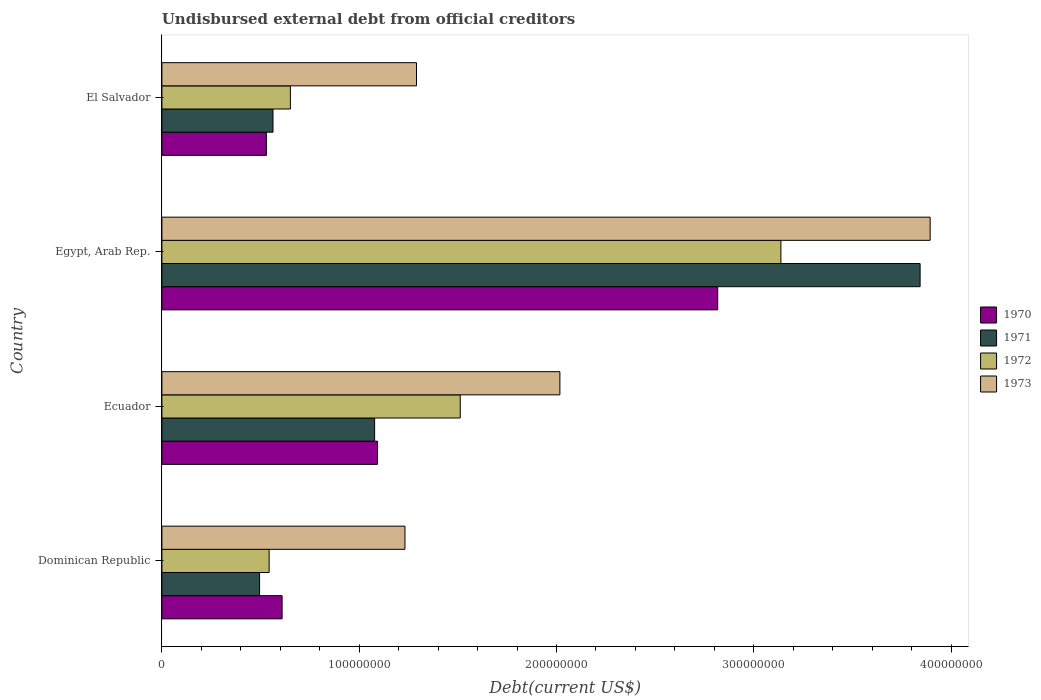How many different coloured bars are there?
Provide a succinct answer. 4. Are the number of bars on each tick of the Y-axis equal?
Make the answer very short. Yes. How many bars are there on the 4th tick from the top?
Make the answer very short. 4. How many bars are there on the 4th tick from the bottom?
Offer a very short reply. 4. What is the label of the 4th group of bars from the top?
Keep it short and to the point. Dominican Republic. What is the total debt in 1970 in Ecuador?
Offer a very short reply. 1.09e+08. Across all countries, what is the maximum total debt in 1972?
Your response must be concise. 3.14e+08. Across all countries, what is the minimum total debt in 1973?
Ensure brevity in your answer.  1.23e+08. In which country was the total debt in 1971 maximum?
Your answer should be very brief. Egypt, Arab Rep. In which country was the total debt in 1971 minimum?
Give a very brief answer. Dominican Republic. What is the total total debt in 1970 in the graph?
Your response must be concise. 5.05e+08. What is the difference between the total debt in 1970 in Dominican Republic and that in Egypt, Arab Rep.?
Offer a very short reply. -2.21e+08. What is the difference between the total debt in 1972 in Dominican Republic and the total debt in 1971 in El Salvador?
Give a very brief answer. -1.96e+06. What is the average total debt in 1971 per country?
Ensure brevity in your answer.  1.49e+08. What is the difference between the total debt in 1971 and total debt in 1972 in Dominican Republic?
Make the answer very short. -4.85e+06. In how many countries, is the total debt in 1972 greater than 100000000 US$?
Provide a succinct answer. 2. What is the ratio of the total debt in 1972 in Dominican Republic to that in Egypt, Arab Rep.?
Give a very brief answer. 0.17. Is the total debt in 1970 in Ecuador less than that in Egypt, Arab Rep.?
Provide a short and direct response. Yes. What is the difference between the highest and the second highest total debt in 1970?
Offer a terse response. 1.72e+08. What is the difference between the highest and the lowest total debt in 1971?
Your answer should be very brief. 3.35e+08. In how many countries, is the total debt in 1972 greater than the average total debt in 1972 taken over all countries?
Keep it short and to the point. 2. Is it the case that in every country, the sum of the total debt in 1973 and total debt in 1970 is greater than the sum of total debt in 1971 and total debt in 1972?
Your answer should be very brief. No. Is it the case that in every country, the sum of the total debt in 1970 and total debt in 1973 is greater than the total debt in 1972?
Provide a succinct answer. Yes. Are all the bars in the graph horizontal?
Ensure brevity in your answer.  Yes. Are the values on the major ticks of X-axis written in scientific E-notation?
Keep it short and to the point. No. Does the graph contain any zero values?
Ensure brevity in your answer.  No. Where does the legend appear in the graph?
Provide a succinct answer. Center right. What is the title of the graph?
Your response must be concise. Undisbursed external debt from official creditors. Does "1981" appear as one of the legend labels in the graph?
Keep it short and to the point. No. What is the label or title of the X-axis?
Offer a terse response. Debt(current US$). What is the Debt(current US$) in 1970 in Dominican Republic?
Your response must be concise. 6.09e+07. What is the Debt(current US$) in 1971 in Dominican Republic?
Give a very brief answer. 4.95e+07. What is the Debt(current US$) in 1972 in Dominican Republic?
Your response must be concise. 5.44e+07. What is the Debt(current US$) of 1973 in Dominican Republic?
Provide a succinct answer. 1.23e+08. What is the Debt(current US$) in 1970 in Ecuador?
Keep it short and to the point. 1.09e+08. What is the Debt(current US$) of 1971 in Ecuador?
Your answer should be very brief. 1.08e+08. What is the Debt(current US$) in 1972 in Ecuador?
Give a very brief answer. 1.51e+08. What is the Debt(current US$) in 1973 in Ecuador?
Give a very brief answer. 2.02e+08. What is the Debt(current US$) in 1970 in Egypt, Arab Rep.?
Offer a terse response. 2.82e+08. What is the Debt(current US$) of 1971 in Egypt, Arab Rep.?
Provide a short and direct response. 3.84e+08. What is the Debt(current US$) of 1972 in Egypt, Arab Rep.?
Keep it short and to the point. 3.14e+08. What is the Debt(current US$) of 1973 in Egypt, Arab Rep.?
Your answer should be very brief. 3.89e+08. What is the Debt(current US$) in 1970 in El Salvador?
Your response must be concise. 5.30e+07. What is the Debt(current US$) in 1971 in El Salvador?
Ensure brevity in your answer.  5.63e+07. What is the Debt(current US$) in 1972 in El Salvador?
Offer a very short reply. 6.51e+07. What is the Debt(current US$) in 1973 in El Salvador?
Your answer should be very brief. 1.29e+08. Across all countries, what is the maximum Debt(current US$) in 1970?
Make the answer very short. 2.82e+08. Across all countries, what is the maximum Debt(current US$) of 1971?
Provide a short and direct response. 3.84e+08. Across all countries, what is the maximum Debt(current US$) of 1972?
Provide a succinct answer. 3.14e+08. Across all countries, what is the maximum Debt(current US$) of 1973?
Give a very brief answer. 3.89e+08. Across all countries, what is the minimum Debt(current US$) of 1970?
Your answer should be compact. 5.30e+07. Across all countries, what is the minimum Debt(current US$) in 1971?
Provide a succinct answer. 4.95e+07. Across all countries, what is the minimum Debt(current US$) in 1972?
Provide a succinct answer. 5.44e+07. Across all countries, what is the minimum Debt(current US$) in 1973?
Ensure brevity in your answer.  1.23e+08. What is the total Debt(current US$) in 1970 in the graph?
Offer a very short reply. 5.05e+08. What is the total Debt(current US$) of 1971 in the graph?
Offer a very short reply. 5.98e+08. What is the total Debt(current US$) of 1972 in the graph?
Make the answer very short. 5.84e+08. What is the total Debt(current US$) of 1973 in the graph?
Your response must be concise. 8.43e+08. What is the difference between the Debt(current US$) of 1970 in Dominican Republic and that in Ecuador?
Provide a short and direct response. -4.84e+07. What is the difference between the Debt(current US$) in 1971 in Dominican Republic and that in Ecuador?
Provide a short and direct response. -5.83e+07. What is the difference between the Debt(current US$) of 1972 in Dominican Republic and that in Ecuador?
Your answer should be compact. -9.69e+07. What is the difference between the Debt(current US$) in 1973 in Dominican Republic and that in Ecuador?
Offer a very short reply. -7.85e+07. What is the difference between the Debt(current US$) of 1970 in Dominican Republic and that in Egypt, Arab Rep.?
Provide a short and direct response. -2.21e+08. What is the difference between the Debt(current US$) of 1971 in Dominican Republic and that in Egypt, Arab Rep.?
Provide a short and direct response. -3.35e+08. What is the difference between the Debt(current US$) of 1972 in Dominican Republic and that in Egypt, Arab Rep.?
Keep it short and to the point. -2.59e+08. What is the difference between the Debt(current US$) of 1973 in Dominican Republic and that in Egypt, Arab Rep.?
Keep it short and to the point. -2.66e+08. What is the difference between the Debt(current US$) of 1970 in Dominican Republic and that in El Salvador?
Provide a short and direct response. 7.96e+06. What is the difference between the Debt(current US$) in 1971 in Dominican Republic and that in El Salvador?
Make the answer very short. -6.81e+06. What is the difference between the Debt(current US$) in 1972 in Dominican Republic and that in El Salvador?
Your answer should be very brief. -1.08e+07. What is the difference between the Debt(current US$) in 1973 in Dominican Republic and that in El Salvador?
Your answer should be compact. -5.85e+06. What is the difference between the Debt(current US$) in 1970 in Ecuador and that in Egypt, Arab Rep.?
Your answer should be very brief. -1.72e+08. What is the difference between the Debt(current US$) of 1971 in Ecuador and that in Egypt, Arab Rep.?
Your answer should be compact. -2.76e+08. What is the difference between the Debt(current US$) of 1972 in Ecuador and that in Egypt, Arab Rep.?
Make the answer very short. -1.63e+08. What is the difference between the Debt(current US$) of 1973 in Ecuador and that in Egypt, Arab Rep.?
Make the answer very short. -1.88e+08. What is the difference between the Debt(current US$) of 1970 in Ecuador and that in El Salvador?
Your response must be concise. 5.63e+07. What is the difference between the Debt(current US$) in 1971 in Ecuador and that in El Salvador?
Your answer should be compact. 5.15e+07. What is the difference between the Debt(current US$) in 1972 in Ecuador and that in El Salvador?
Your response must be concise. 8.61e+07. What is the difference between the Debt(current US$) of 1973 in Ecuador and that in El Salvador?
Your answer should be very brief. 7.27e+07. What is the difference between the Debt(current US$) of 1970 in Egypt, Arab Rep. and that in El Salvador?
Offer a very short reply. 2.29e+08. What is the difference between the Debt(current US$) of 1971 in Egypt, Arab Rep. and that in El Salvador?
Make the answer very short. 3.28e+08. What is the difference between the Debt(current US$) of 1972 in Egypt, Arab Rep. and that in El Salvador?
Provide a succinct answer. 2.49e+08. What is the difference between the Debt(current US$) in 1973 in Egypt, Arab Rep. and that in El Salvador?
Offer a terse response. 2.60e+08. What is the difference between the Debt(current US$) of 1970 in Dominican Republic and the Debt(current US$) of 1971 in Ecuador?
Provide a short and direct response. -4.69e+07. What is the difference between the Debt(current US$) in 1970 in Dominican Republic and the Debt(current US$) in 1972 in Ecuador?
Offer a terse response. -9.03e+07. What is the difference between the Debt(current US$) of 1970 in Dominican Republic and the Debt(current US$) of 1973 in Ecuador?
Give a very brief answer. -1.41e+08. What is the difference between the Debt(current US$) in 1971 in Dominican Republic and the Debt(current US$) in 1972 in Ecuador?
Make the answer very short. -1.02e+08. What is the difference between the Debt(current US$) in 1971 in Dominican Republic and the Debt(current US$) in 1973 in Ecuador?
Give a very brief answer. -1.52e+08. What is the difference between the Debt(current US$) in 1972 in Dominican Republic and the Debt(current US$) in 1973 in Ecuador?
Keep it short and to the point. -1.47e+08. What is the difference between the Debt(current US$) in 1970 in Dominican Republic and the Debt(current US$) in 1971 in Egypt, Arab Rep.?
Your answer should be very brief. -3.23e+08. What is the difference between the Debt(current US$) in 1970 in Dominican Republic and the Debt(current US$) in 1972 in Egypt, Arab Rep.?
Your answer should be compact. -2.53e+08. What is the difference between the Debt(current US$) in 1970 in Dominican Republic and the Debt(current US$) in 1973 in Egypt, Arab Rep.?
Your response must be concise. -3.28e+08. What is the difference between the Debt(current US$) of 1971 in Dominican Republic and the Debt(current US$) of 1972 in Egypt, Arab Rep.?
Your answer should be compact. -2.64e+08. What is the difference between the Debt(current US$) of 1971 in Dominican Republic and the Debt(current US$) of 1973 in Egypt, Arab Rep.?
Your response must be concise. -3.40e+08. What is the difference between the Debt(current US$) of 1972 in Dominican Republic and the Debt(current US$) of 1973 in Egypt, Arab Rep.?
Ensure brevity in your answer.  -3.35e+08. What is the difference between the Debt(current US$) in 1970 in Dominican Republic and the Debt(current US$) in 1971 in El Salvador?
Your answer should be very brief. 4.62e+06. What is the difference between the Debt(current US$) in 1970 in Dominican Republic and the Debt(current US$) in 1972 in El Salvador?
Give a very brief answer. -4.20e+06. What is the difference between the Debt(current US$) in 1970 in Dominican Republic and the Debt(current US$) in 1973 in El Salvador?
Your answer should be very brief. -6.81e+07. What is the difference between the Debt(current US$) of 1971 in Dominican Republic and the Debt(current US$) of 1972 in El Salvador?
Your answer should be compact. -1.56e+07. What is the difference between the Debt(current US$) of 1971 in Dominican Republic and the Debt(current US$) of 1973 in El Salvador?
Provide a succinct answer. -7.95e+07. What is the difference between the Debt(current US$) of 1972 in Dominican Republic and the Debt(current US$) of 1973 in El Salvador?
Offer a very short reply. -7.47e+07. What is the difference between the Debt(current US$) in 1970 in Ecuador and the Debt(current US$) in 1971 in Egypt, Arab Rep.?
Provide a succinct answer. -2.75e+08. What is the difference between the Debt(current US$) in 1970 in Ecuador and the Debt(current US$) in 1972 in Egypt, Arab Rep.?
Your answer should be very brief. -2.04e+08. What is the difference between the Debt(current US$) in 1970 in Ecuador and the Debt(current US$) in 1973 in Egypt, Arab Rep.?
Your answer should be compact. -2.80e+08. What is the difference between the Debt(current US$) in 1971 in Ecuador and the Debt(current US$) in 1972 in Egypt, Arab Rep.?
Your answer should be compact. -2.06e+08. What is the difference between the Debt(current US$) of 1971 in Ecuador and the Debt(current US$) of 1973 in Egypt, Arab Rep.?
Give a very brief answer. -2.82e+08. What is the difference between the Debt(current US$) of 1972 in Ecuador and the Debt(current US$) of 1973 in Egypt, Arab Rep.?
Give a very brief answer. -2.38e+08. What is the difference between the Debt(current US$) of 1970 in Ecuador and the Debt(current US$) of 1971 in El Salvador?
Your answer should be compact. 5.30e+07. What is the difference between the Debt(current US$) of 1970 in Ecuador and the Debt(current US$) of 1972 in El Salvador?
Ensure brevity in your answer.  4.42e+07. What is the difference between the Debt(current US$) in 1970 in Ecuador and the Debt(current US$) in 1973 in El Salvador?
Your answer should be very brief. -1.98e+07. What is the difference between the Debt(current US$) of 1971 in Ecuador and the Debt(current US$) of 1972 in El Salvador?
Your answer should be very brief. 4.27e+07. What is the difference between the Debt(current US$) of 1971 in Ecuador and the Debt(current US$) of 1973 in El Salvador?
Your answer should be compact. -2.12e+07. What is the difference between the Debt(current US$) in 1972 in Ecuador and the Debt(current US$) in 1973 in El Salvador?
Keep it short and to the point. 2.22e+07. What is the difference between the Debt(current US$) in 1970 in Egypt, Arab Rep. and the Debt(current US$) in 1971 in El Salvador?
Your answer should be compact. 2.25e+08. What is the difference between the Debt(current US$) in 1970 in Egypt, Arab Rep. and the Debt(current US$) in 1972 in El Salvador?
Ensure brevity in your answer.  2.17e+08. What is the difference between the Debt(current US$) in 1970 in Egypt, Arab Rep. and the Debt(current US$) in 1973 in El Salvador?
Your answer should be very brief. 1.53e+08. What is the difference between the Debt(current US$) in 1971 in Egypt, Arab Rep. and the Debt(current US$) in 1972 in El Salvador?
Offer a very short reply. 3.19e+08. What is the difference between the Debt(current US$) of 1971 in Egypt, Arab Rep. and the Debt(current US$) of 1973 in El Salvador?
Your response must be concise. 2.55e+08. What is the difference between the Debt(current US$) in 1972 in Egypt, Arab Rep. and the Debt(current US$) in 1973 in El Salvador?
Keep it short and to the point. 1.85e+08. What is the average Debt(current US$) in 1970 per country?
Ensure brevity in your answer.  1.26e+08. What is the average Debt(current US$) of 1971 per country?
Make the answer very short. 1.49e+08. What is the average Debt(current US$) of 1972 per country?
Your answer should be very brief. 1.46e+08. What is the average Debt(current US$) of 1973 per country?
Offer a very short reply. 2.11e+08. What is the difference between the Debt(current US$) of 1970 and Debt(current US$) of 1971 in Dominican Republic?
Offer a very short reply. 1.14e+07. What is the difference between the Debt(current US$) of 1970 and Debt(current US$) of 1972 in Dominican Republic?
Keep it short and to the point. 6.57e+06. What is the difference between the Debt(current US$) of 1970 and Debt(current US$) of 1973 in Dominican Republic?
Your answer should be compact. -6.23e+07. What is the difference between the Debt(current US$) of 1971 and Debt(current US$) of 1972 in Dominican Republic?
Make the answer very short. -4.85e+06. What is the difference between the Debt(current US$) of 1971 and Debt(current US$) of 1973 in Dominican Republic?
Your answer should be very brief. -7.37e+07. What is the difference between the Debt(current US$) of 1972 and Debt(current US$) of 1973 in Dominican Republic?
Make the answer very short. -6.88e+07. What is the difference between the Debt(current US$) in 1970 and Debt(current US$) in 1971 in Ecuador?
Make the answer very short. 1.47e+06. What is the difference between the Debt(current US$) in 1970 and Debt(current US$) in 1972 in Ecuador?
Your response must be concise. -4.19e+07. What is the difference between the Debt(current US$) in 1970 and Debt(current US$) in 1973 in Ecuador?
Ensure brevity in your answer.  -9.24e+07. What is the difference between the Debt(current US$) in 1971 and Debt(current US$) in 1972 in Ecuador?
Keep it short and to the point. -4.34e+07. What is the difference between the Debt(current US$) of 1971 and Debt(current US$) of 1973 in Ecuador?
Offer a very short reply. -9.39e+07. What is the difference between the Debt(current US$) in 1972 and Debt(current US$) in 1973 in Ecuador?
Give a very brief answer. -5.05e+07. What is the difference between the Debt(current US$) of 1970 and Debt(current US$) of 1971 in Egypt, Arab Rep.?
Your answer should be very brief. -1.03e+08. What is the difference between the Debt(current US$) in 1970 and Debt(current US$) in 1972 in Egypt, Arab Rep.?
Keep it short and to the point. -3.20e+07. What is the difference between the Debt(current US$) in 1970 and Debt(current US$) in 1973 in Egypt, Arab Rep.?
Offer a terse response. -1.08e+08. What is the difference between the Debt(current US$) in 1971 and Debt(current US$) in 1972 in Egypt, Arab Rep.?
Give a very brief answer. 7.06e+07. What is the difference between the Debt(current US$) in 1971 and Debt(current US$) in 1973 in Egypt, Arab Rep.?
Offer a terse response. -5.09e+06. What is the difference between the Debt(current US$) in 1972 and Debt(current US$) in 1973 in Egypt, Arab Rep.?
Give a very brief answer. -7.56e+07. What is the difference between the Debt(current US$) in 1970 and Debt(current US$) in 1971 in El Salvador?
Make the answer very short. -3.35e+06. What is the difference between the Debt(current US$) in 1970 and Debt(current US$) in 1972 in El Salvador?
Provide a succinct answer. -1.22e+07. What is the difference between the Debt(current US$) of 1970 and Debt(current US$) of 1973 in El Salvador?
Offer a very short reply. -7.61e+07. What is the difference between the Debt(current US$) in 1971 and Debt(current US$) in 1972 in El Salvador?
Make the answer very short. -8.81e+06. What is the difference between the Debt(current US$) of 1971 and Debt(current US$) of 1973 in El Salvador?
Give a very brief answer. -7.27e+07. What is the difference between the Debt(current US$) of 1972 and Debt(current US$) of 1973 in El Salvador?
Give a very brief answer. -6.39e+07. What is the ratio of the Debt(current US$) of 1970 in Dominican Republic to that in Ecuador?
Offer a terse response. 0.56. What is the ratio of the Debt(current US$) of 1971 in Dominican Republic to that in Ecuador?
Keep it short and to the point. 0.46. What is the ratio of the Debt(current US$) of 1972 in Dominican Republic to that in Ecuador?
Keep it short and to the point. 0.36. What is the ratio of the Debt(current US$) in 1973 in Dominican Republic to that in Ecuador?
Offer a terse response. 0.61. What is the ratio of the Debt(current US$) of 1970 in Dominican Republic to that in Egypt, Arab Rep.?
Make the answer very short. 0.22. What is the ratio of the Debt(current US$) in 1971 in Dominican Republic to that in Egypt, Arab Rep.?
Ensure brevity in your answer.  0.13. What is the ratio of the Debt(current US$) in 1972 in Dominican Republic to that in Egypt, Arab Rep.?
Your answer should be compact. 0.17. What is the ratio of the Debt(current US$) in 1973 in Dominican Republic to that in Egypt, Arab Rep.?
Your answer should be compact. 0.32. What is the ratio of the Debt(current US$) of 1970 in Dominican Republic to that in El Salvador?
Provide a succinct answer. 1.15. What is the ratio of the Debt(current US$) in 1971 in Dominican Republic to that in El Salvador?
Your answer should be compact. 0.88. What is the ratio of the Debt(current US$) of 1972 in Dominican Republic to that in El Salvador?
Your answer should be compact. 0.83. What is the ratio of the Debt(current US$) in 1973 in Dominican Republic to that in El Salvador?
Make the answer very short. 0.95. What is the ratio of the Debt(current US$) of 1970 in Ecuador to that in Egypt, Arab Rep.?
Offer a very short reply. 0.39. What is the ratio of the Debt(current US$) in 1971 in Ecuador to that in Egypt, Arab Rep.?
Your answer should be very brief. 0.28. What is the ratio of the Debt(current US$) in 1972 in Ecuador to that in Egypt, Arab Rep.?
Offer a very short reply. 0.48. What is the ratio of the Debt(current US$) in 1973 in Ecuador to that in Egypt, Arab Rep.?
Ensure brevity in your answer.  0.52. What is the ratio of the Debt(current US$) in 1970 in Ecuador to that in El Salvador?
Give a very brief answer. 2.06. What is the ratio of the Debt(current US$) of 1971 in Ecuador to that in El Salvador?
Offer a terse response. 1.91. What is the ratio of the Debt(current US$) of 1972 in Ecuador to that in El Salvador?
Give a very brief answer. 2.32. What is the ratio of the Debt(current US$) in 1973 in Ecuador to that in El Salvador?
Your response must be concise. 1.56. What is the ratio of the Debt(current US$) of 1970 in Egypt, Arab Rep. to that in El Salvador?
Give a very brief answer. 5.32. What is the ratio of the Debt(current US$) in 1971 in Egypt, Arab Rep. to that in El Salvador?
Provide a short and direct response. 6.82. What is the ratio of the Debt(current US$) of 1972 in Egypt, Arab Rep. to that in El Salvador?
Provide a short and direct response. 4.82. What is the ratio of the Debt(current US$) of 1973 in Egypt, Arab Rep. to that in El Salvador?
Your response must be concise. 3.02. What is the difference between the highest and the second highest Debt(current US$) of 1970?
Give a very brief answer. 1.72e+08. What is the difference between the highest and the second highest Debt(current US$) in 1971?
Offer a very short reply. 2.76e+08. What is the difference between the highest and the second highest Debt(current US$) in 1972?
Provide a short and direct response. 1.63e+08. What is the difference between the highest and the second highest Debt(current US$) in 1973?
Provide a short and direct response. 1.88e+08. What is the difference between the highest and the lowest Debt(current US$) of 1970?
Provide a succinct answer. 2.29e+08. What is the difference between the highest and the lowest Debt(current US$) of 1971?
Ensure brevity in your answer.  3.35e+08. What is the difference between the highest and the lowest Debt(current US$) of 1972?
Your response must be concise. 2.59e+08. What is the difference between the highest and the lowest Debt(current US$) of 1973?
Your response must be concise. 2.66e+08. 